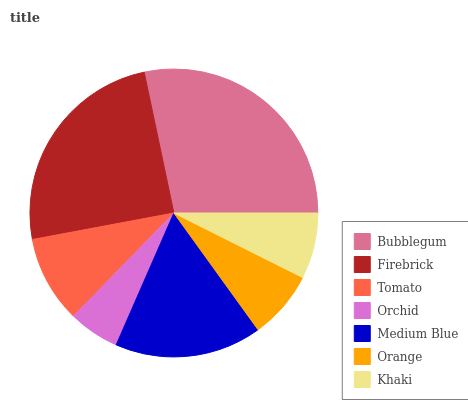Is Orchid the minimum?
Answer yes or no. Yes. Is Bubblegum the maximum?
Answer yes or no. Yes. Is Firebrick the minimum?
Answer yes or no. No. Is Firebrick the maximum?
Answer yes or no. No. Is Bubblegum greater than Firebrick?
Answer yes or no. Yes. Is Firebrick less than Bubblegum?
Answer yes or no. Yes. Is Firebrick greater than Bubblegum?
Answer yes or no. No. Is Bubblegum less than Firebrick?
Answer yes or no. No. Is Tomato the high median?
Answer yes or no. Yes. Is Tomato the low median?
Answer yes or no. Yes. Is Medium Blue the high median?
Answer yes or no. No. Is Orchid the low median?
Answer yes or no. No. 